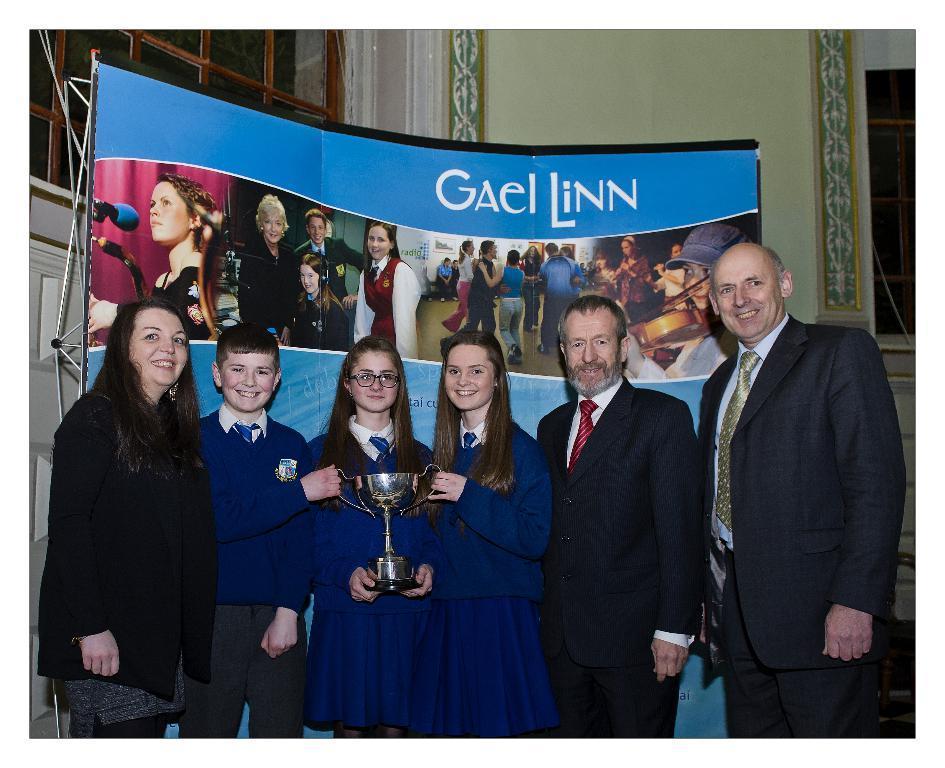How would you summarize this image in a sentence or two? There are some people standing. In that there are students and they are holding a trophy. In the back there is a banner. In the background there is a window and a wall. 